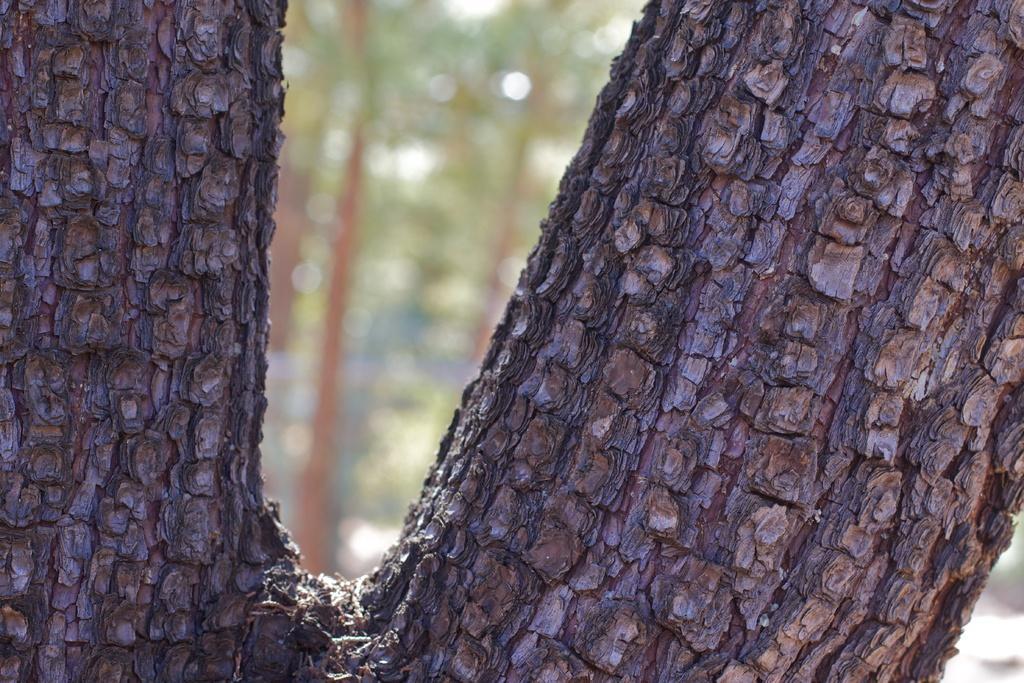In one or two sentences, can you explain what this image depicts? In the foreground of the picture we can see the trunk of a tree. The background is blurred. In the background there is greenery. 